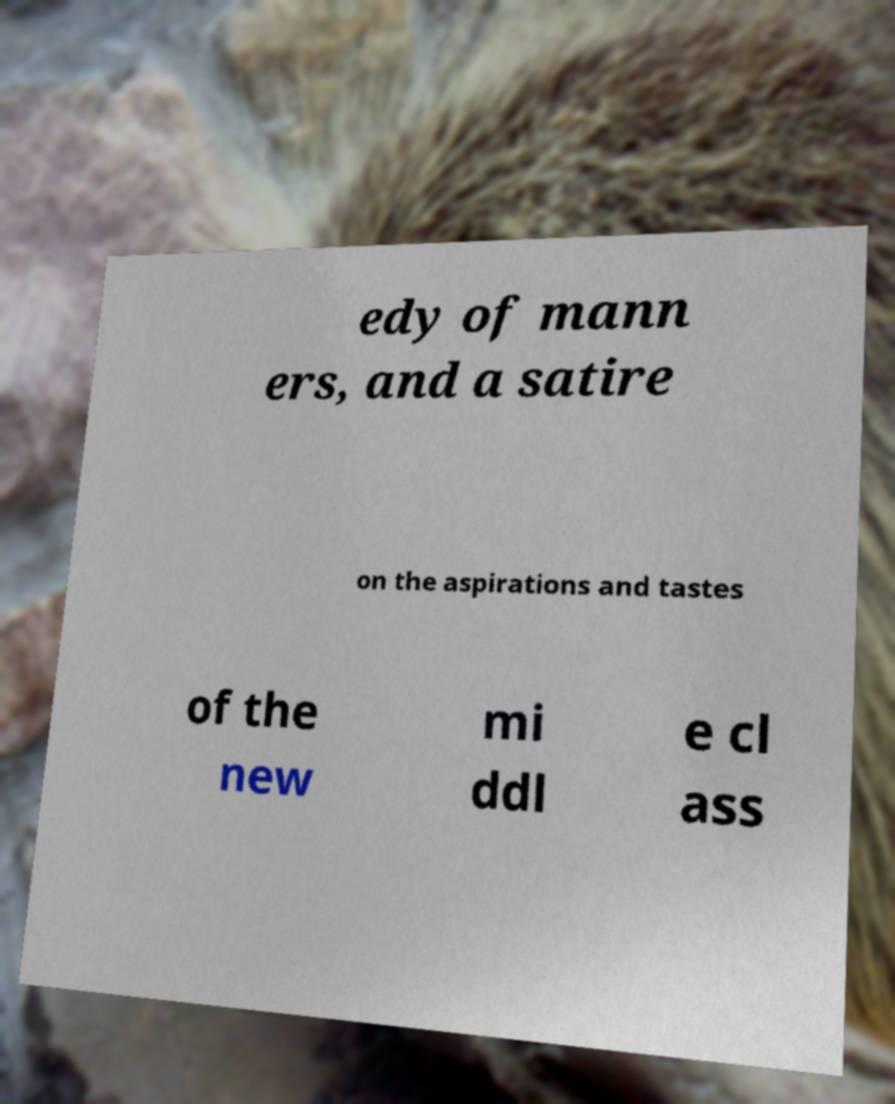For documentation purposes, I need the text within this image transcribed. Could you provide that? edy of mann ers, and a satire on the aspirations and tastes of the new mi ddl e cl ass 